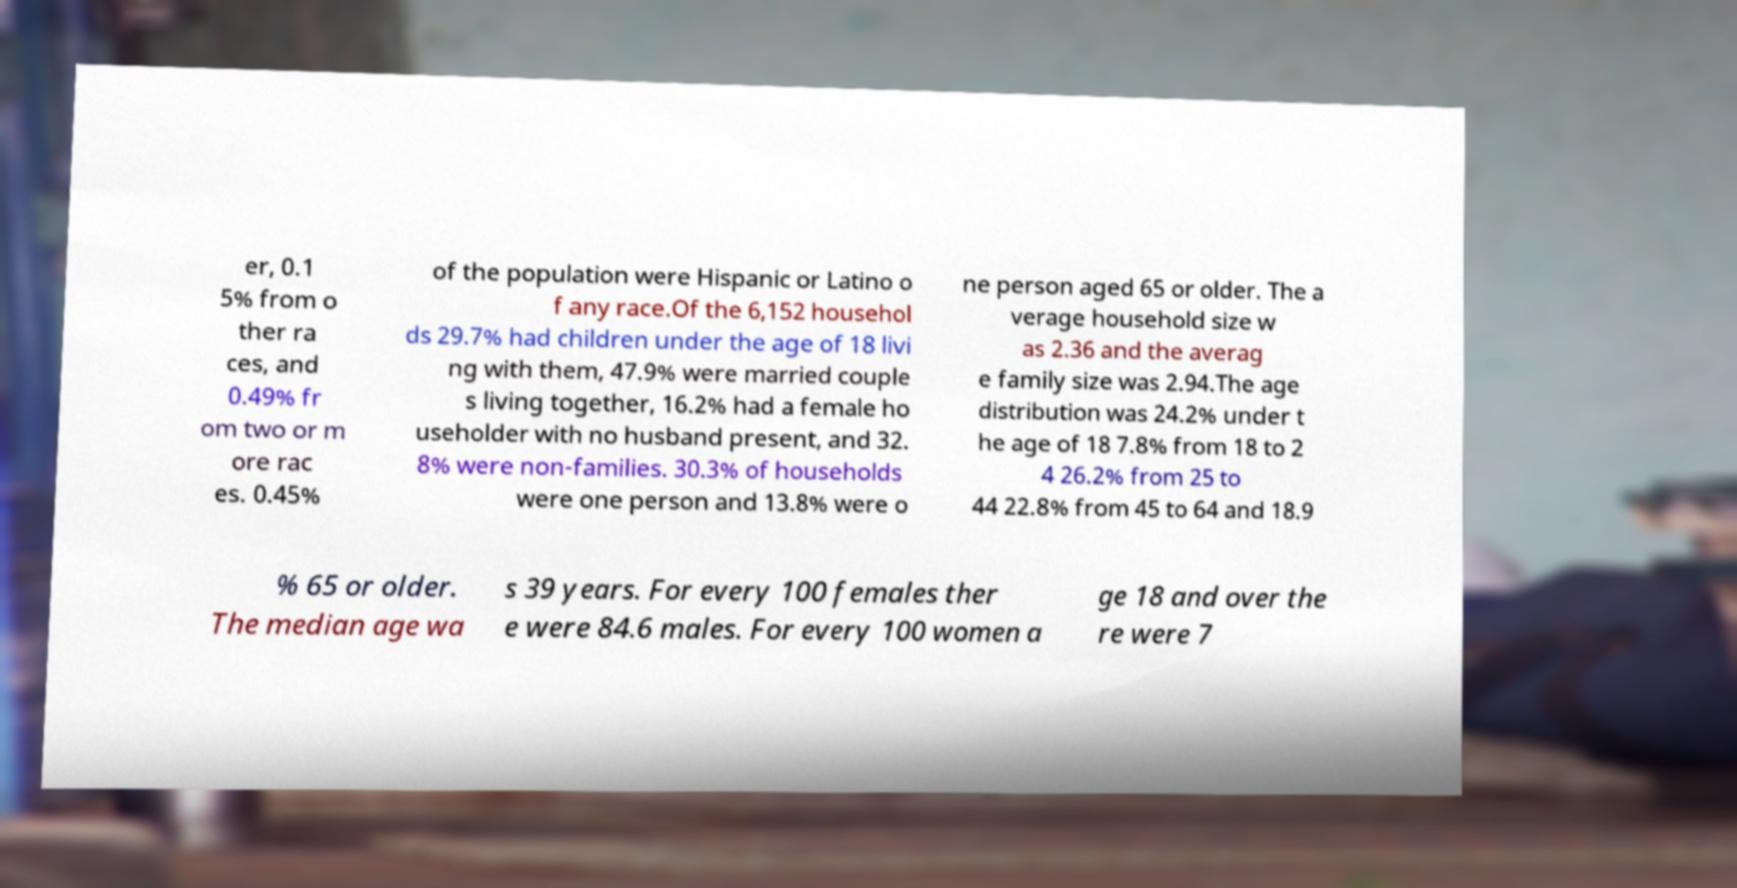Could you assist in decoding the text presented in this image and type it out clearly? er, 0.1 5% from o ther ra ces, and 0.49% fr om two or m ore rac es. 0.45% of the population were Hispanic or Latino o f any race.Of the 6,152 househol ds 29.7% had children under the age of 18 livi ng with them, 47.9% were married couple s living together, 16.2% had a female ho useholder with no husband present, and 32. 8% were non-families. 30.3% of households were one person and 13.8% were o ne person aged 65 or older. The a verage household size w as 2.36 and the averag e family size was 2.94.The age distribution was 24.2% under t he age of 18 7.8% from 18 to 2 4 26.2% from 25 to 44 22.8% from 45 to 64 and 18.9 % 65 or older. The median age wa s 39 years. For every 100 females ther e were 84.6 males. For every 100 women a ge 18 and over the re were 7 